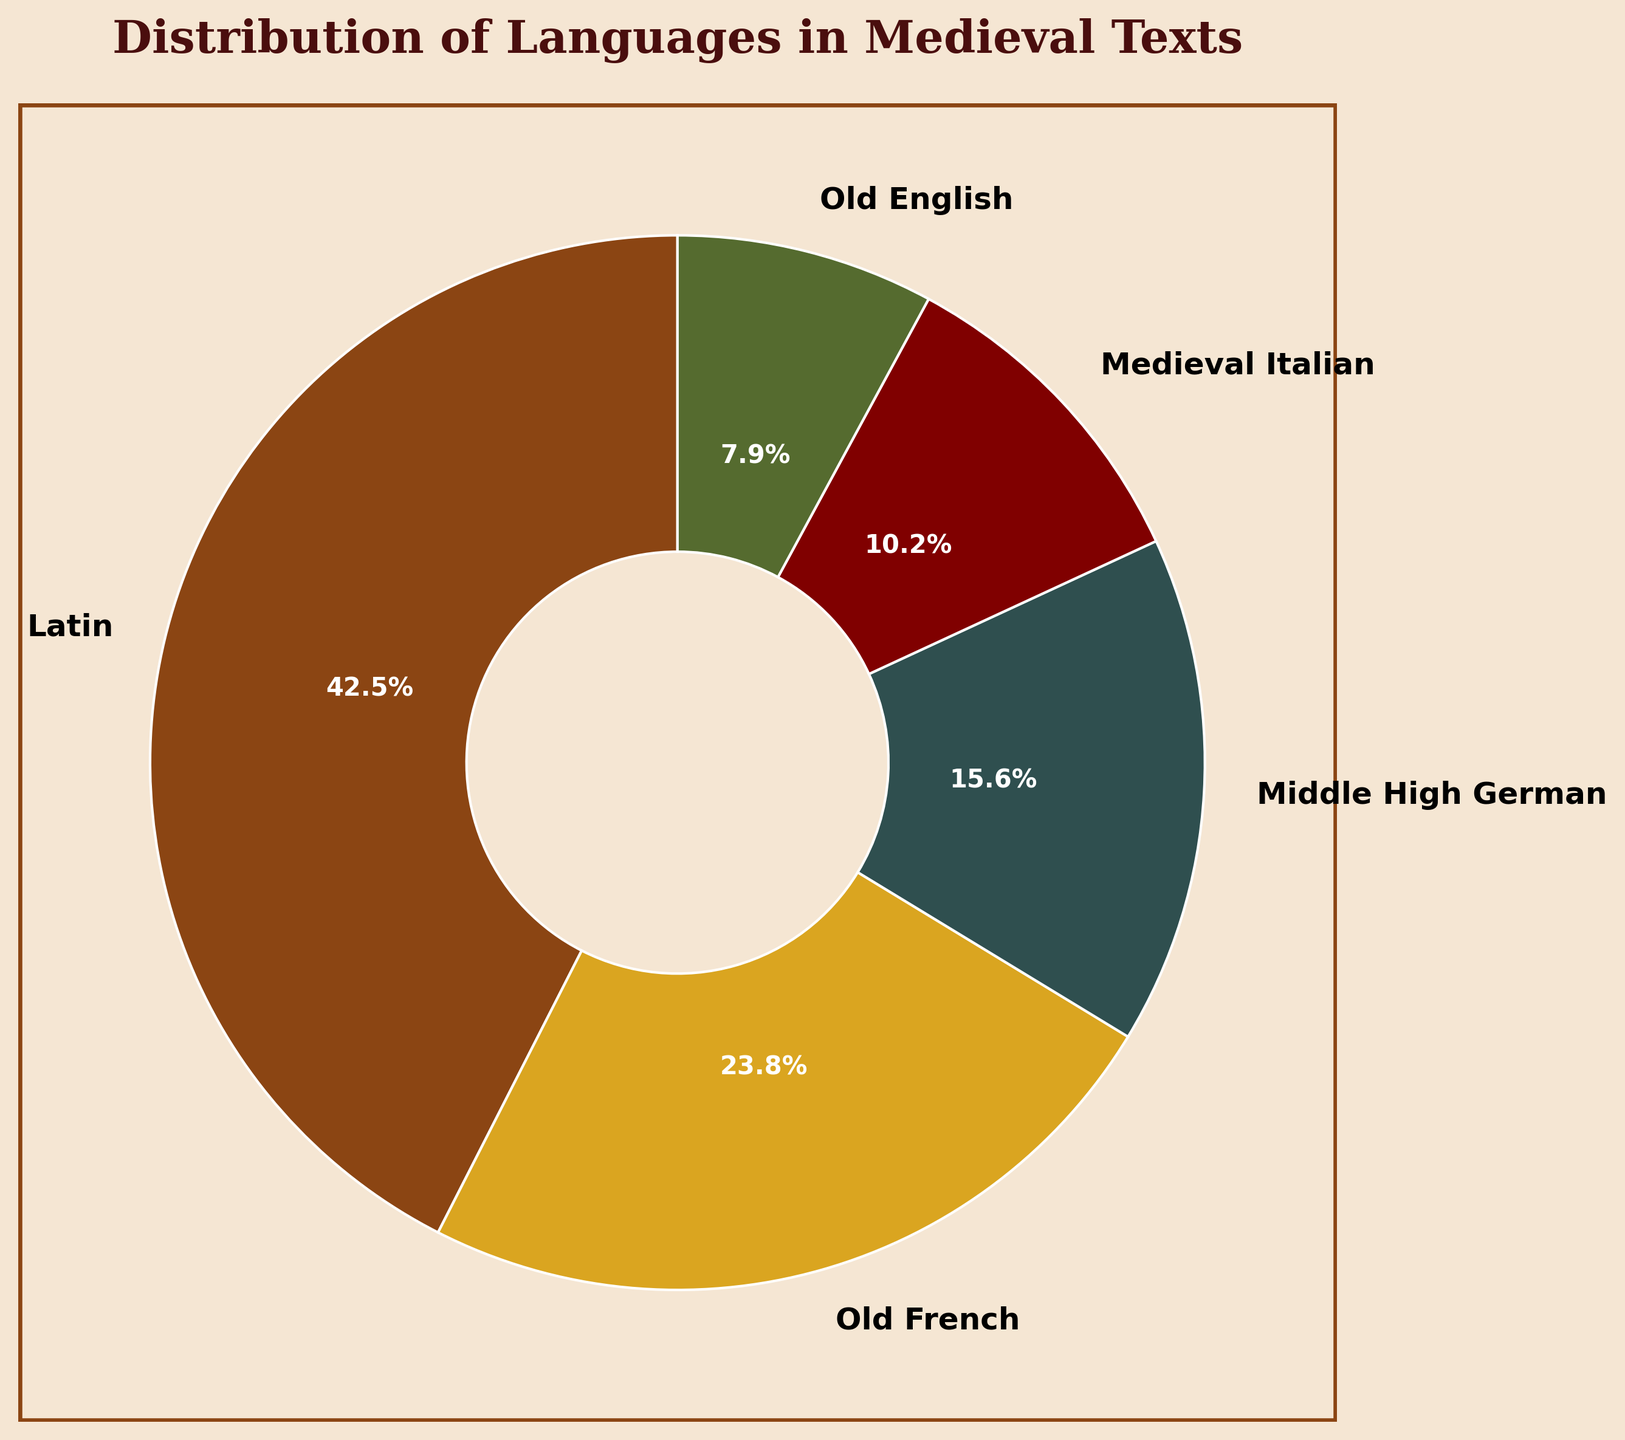What percentage of the medieval texts are written in Latin? The pie chart indicates the percentage distribution of each language. The slice representing Latin shows 42.5%.
Answer: 42.5% Which language occupies the second largest portion of the medieval texts? Observing the size of the pie slices, the second largest slice represents Old French.
Answer: Old French How much more prevalent is Latin compared to Old English in medieval texts? Latin has a percentage of 42.5%, while Old English has 7.9%. The difference is 42.5% - 7.9% = 34.6%.
Answer: 34.6% Compare the combined percentage of texts written in Middle High German and Medieval Italian to the percentage of texts written in Latin. Middle High German and Medieval Italian combined are 15.6% + 10.2% = 25.8%. Latin is 42.5%.
Answer: 42.5% is greater Which languages together make up less than 20% of the total medieval texts? Adding the percentages of Old English (7.9%) and Medieval Italian (10.2%) gives 7.9% + 10.2% = 18.1%, which is less than 20%.
Answer: Old English, Medieval Italian How do the proportions of texts written in Old French and Middle High German compare visually? The visual proportions show Old French as a significantly larger slice than Middle High German, indicating Old French has a higher percentage.
Answer: Old French is larger Which language slice is depicted with the color resembling gold? The slice with the golden color represents Old French as per the color theme.
Answer: Old French In which color is the smallest segment of the pie chart represented, and what language does this correspond to? The smallest segment is in a dark green color, representing Old English.
Answer: Dark green, Old English Calculate the average percentage of texts written in Old French, Middle High German, and Medieval Italian. Adding the percentages: 23.8% (Old French), 15.6% (Middle High German), and 10.2% (Medieval Italian), gives 23.8% + 15.6% + 10.2% = 49.6%. The average is 49.6% / 3 ≈ 16.5%.
Answer: 16.5% What visual information can you derive about the relationship between the percentages for Latin and the other languages combined? Latin covers a much larger proportion (42.5%) of the pie chart compared to the total of all other slices (57.5%). Visually, the Latin slice dominates.
Answer: Latin is dominant 